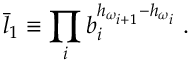<formula> <loc_0><loc_0><loc_500><loc_500>\bar { l } _ { 1 } \equiv \prod _ { i } b _ { i } ^ { h _ { \omega _ { i + 1 } } - h _ { \omega _ { i } } } \, .</formula> 